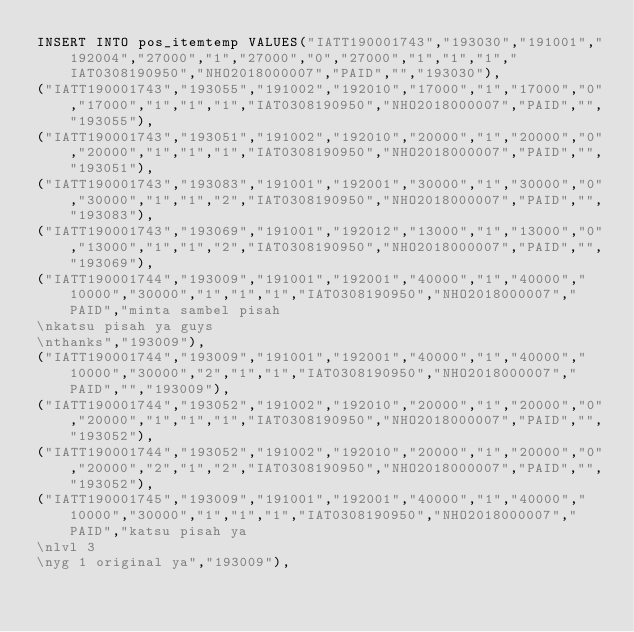Convert code to text. <code><loc_0><loc_0><loc_500><loc_500><_SQL_>INSERT INTO pos_itemtemp VALUES("IATT190001743","193030","191001","192004","27000","1","27000","0","27000","1","1","1","IAT0308190950","NHO2018000007","PAID","","193030"),
("IATT190001743","193055","191002","192010","17000","1","17000","0","17000","1","1","1","IAT0308190950","NHO2018000007","PAID","","193055"),
("IATT190001743","193051","191002","192010","20000","1","20000","0","20000","1","1","1","IAT0308190950","NHO2018000007","PAID","","193051"),
("IATT190001743","193083","191001","192001","30000","1","30000","0","30000","1","1","2","IAT0308190950","NHO2018000007","PAID","","193083"),
("IATT190001743","193069","191001","192012","13000","1","13000","0","13000","1","1","2","IAT0308190950","NHO2018000007","PAID","","193069"),
("IATT190001744","193009","191001","192001","40000","1","40000","10000","30000","1","1","1","IAT0308190950","NHO2018000007","PAID","minta sambel pisah\nkatsu pisah ya guys\nthanks","193009"),
("IATT190001744","193009","191001","192001","40000","1","40000","10000","30000","2","1","1","IAT0308190950","NHO2018000007","PAID","","193009"),
("IATT190001744","193052","191002","192010","20000","1","20000","0","20000","1","1","1","IAT0308190950","NHO2018000007","PAID","","193052"),
("IATT190001744","193052","191002","192010","20000","1","20000","0","20000","2","1","2","IAT0308190950","NHO2018000007","PAID","","193052"),
("IATT190001745","193009","191001","192001","40000","1","40000","10000","30000","1","1","1","IAT0308190950","NHO2018000007","PAID","katsu pisah ya\nlvl 3\nyg 1 original ya","193009"),</code> 